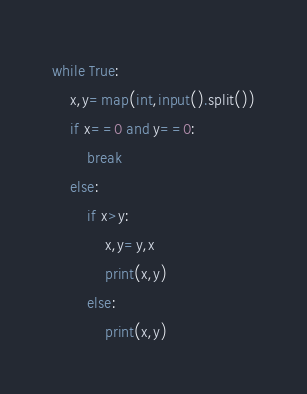<code> <loc_0><loc_0><loc_500><loc_500><_Python_>while True:
    x,y=map(int,input().split())
    if x==0 and y==0:
        break
    else:
        if x>y:
            x,y=y,x
            print(x,y)
        else:
            print(x,y)

</code> 